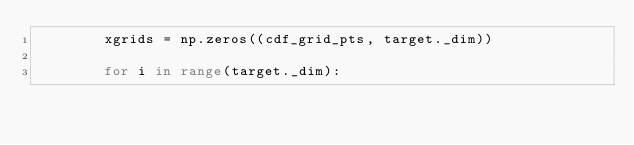Convert code to text. <code><loc_0><loc_0><loc_500><loc_500><_Python_>        xgrids = np.zeros((cdf_grid_pts, target._dim))

        for i in range(target._dim):</code> 